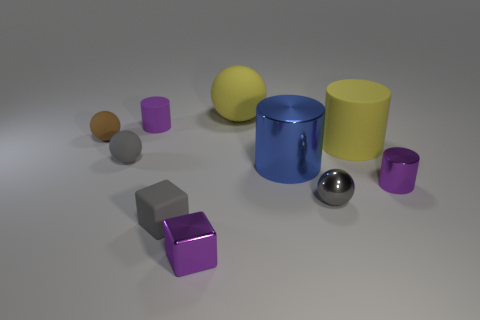What material is the cube that is the same color as the small metallic cylinder?
Your response must be concise. Metal. How many rubber cylinders have the same color as the tiny metal block?
Provide a short and direct response. 1. Does the rubber cube have the same color as the tiny metal sphere?
Provide a short and direct response. Yes. There is a object behind the purple cylinder that is on the left side of the big yellow thing that is to the left of the yellow cylinder; what is it made of?
Keep it short and to the point. Rubber. What number of things are big yellow spheres left of the small gray shiny object or big yellow balls?
Make the answer very short. 1. There is a small ball on the right side of the gray cube; how many yellow objects are on the left side of it?
Provide a succinct answer. 1. There is a gray shiny thing that is in front of the matte ball that is on the right side of the gray sphere that is left of the large matte ball; what size is it?
Your response must be concise. Small. There is a matte cylinder that is on the left side of the big yellow cylinder; is its color the same as the big metallic cylinder?
Your response must be concise. No. There is a yellow matte object that is the same shape as the small brown object; what is its size?
Your answer should be compact. Large. How many objects are either small purple metal objects behind the metallic sphere or metallic objects that are to the left of the tiny gray metal ball?
Offer a very short reply. 3. 